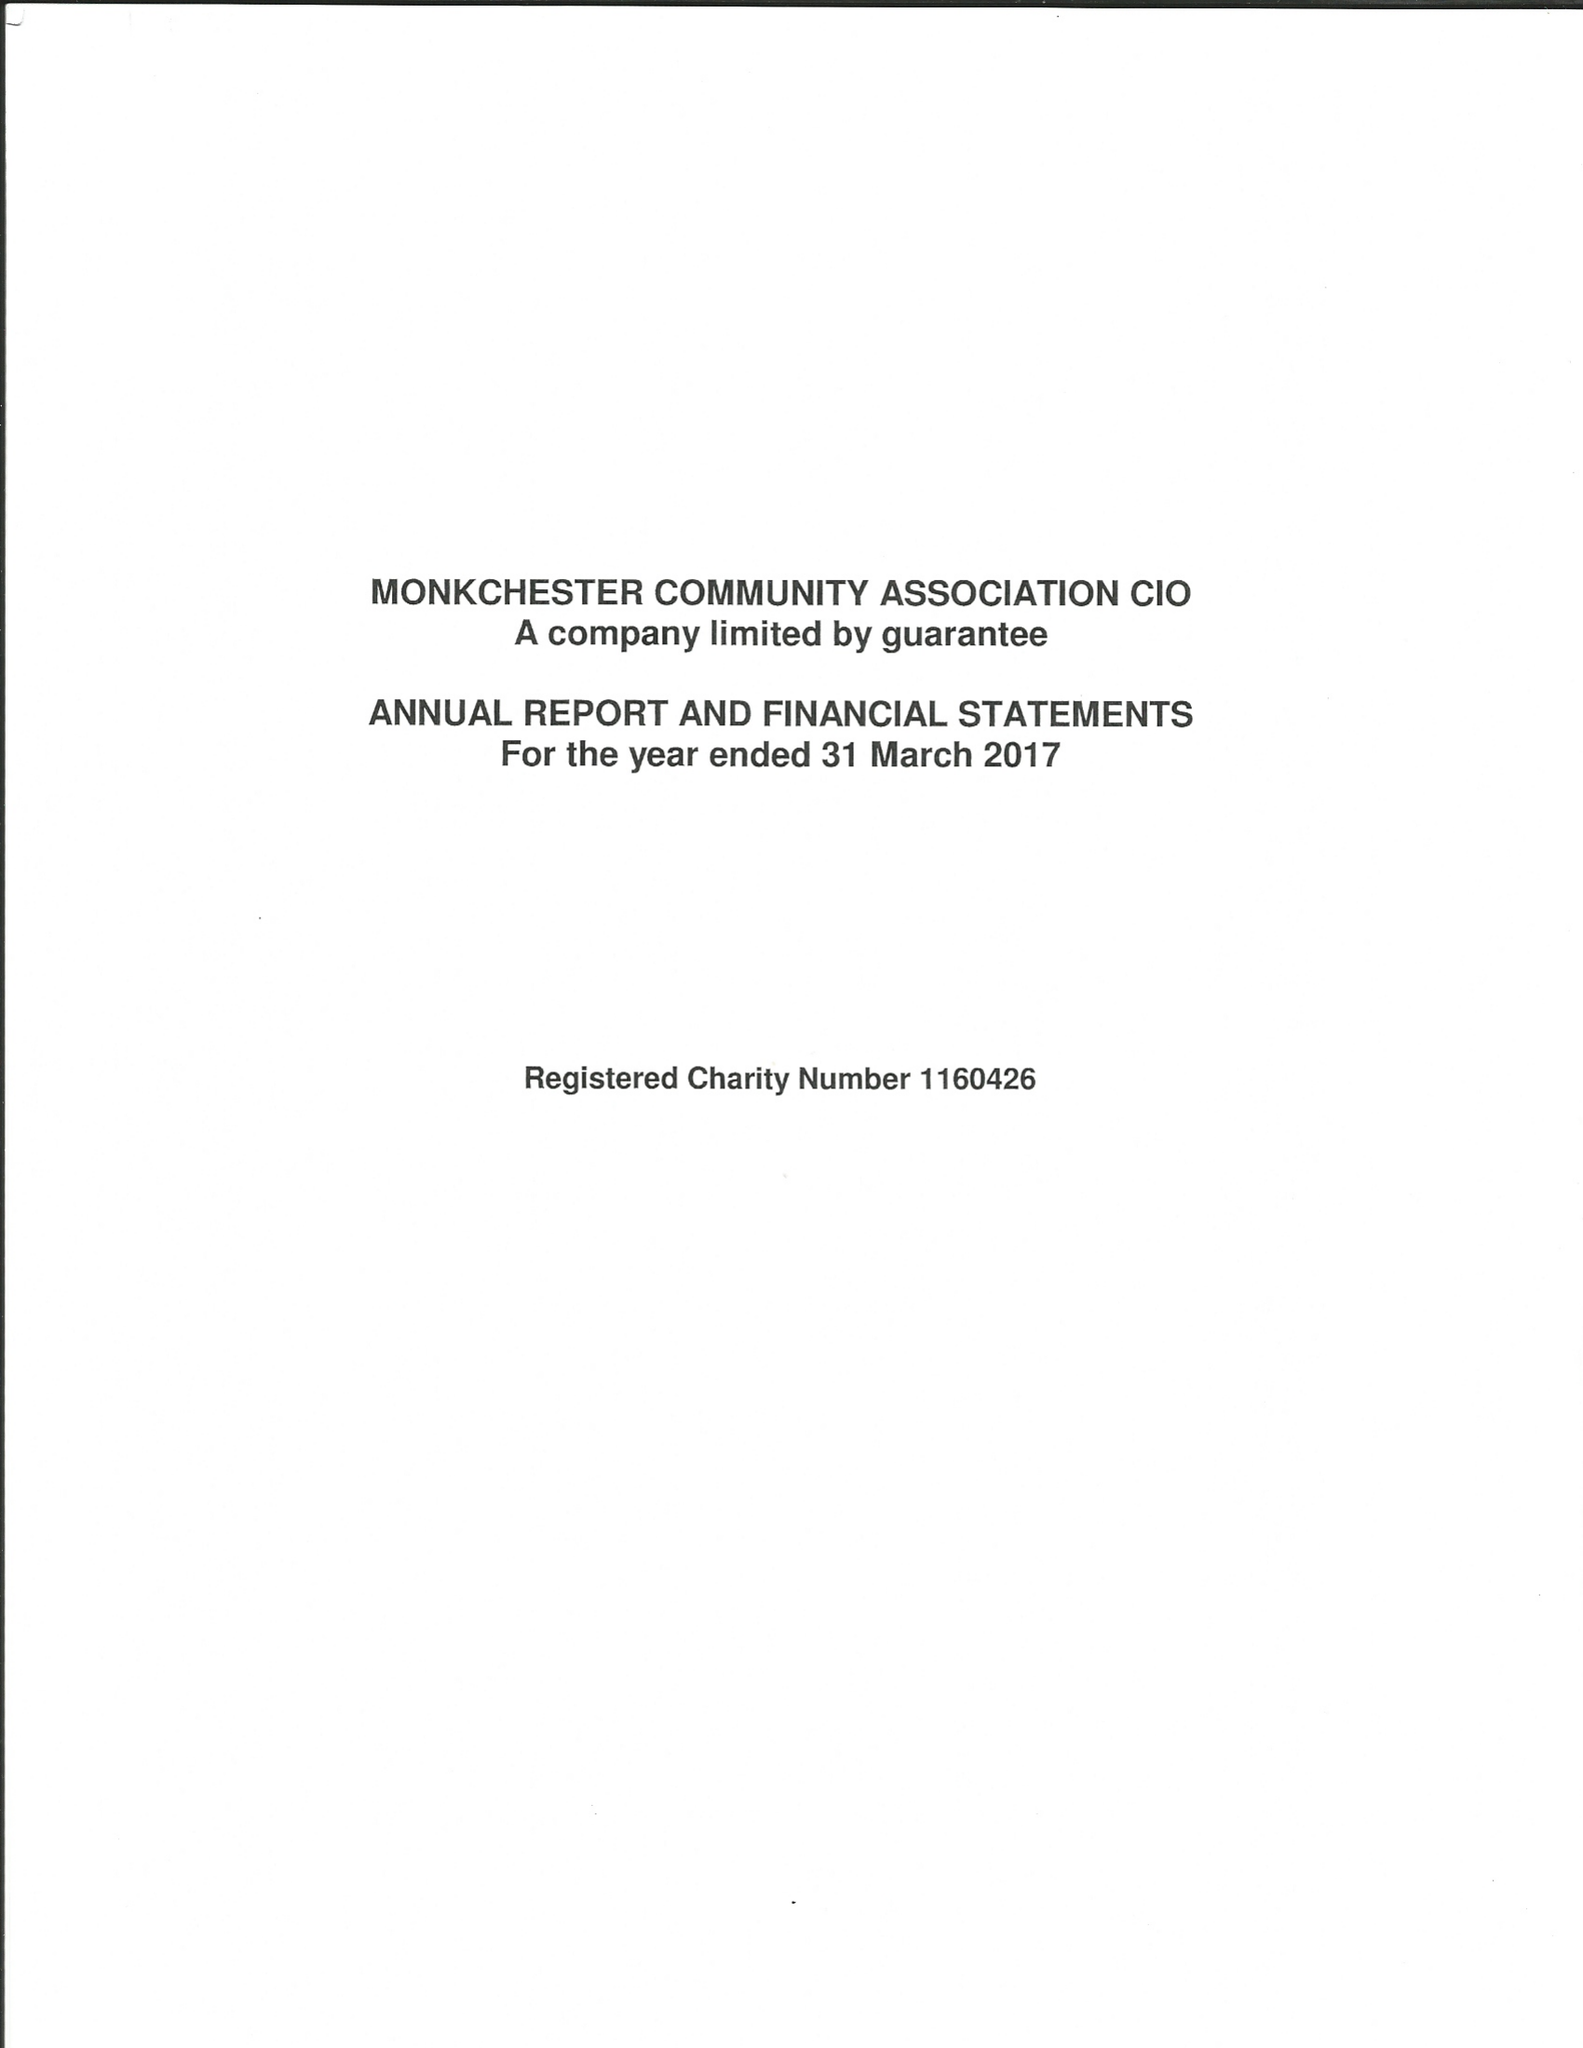What is the value for the charity_name?
Answer the question using a single word or phrase. Monkchester Community Association CIO 